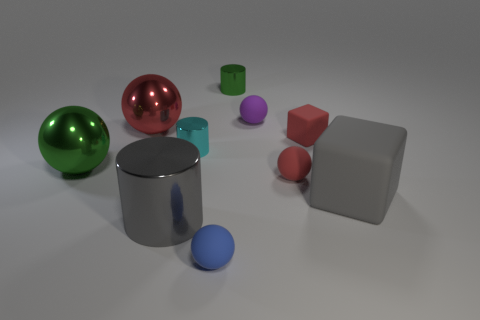The metallic object that is the same color as the large matte thing is what size?
Provide a short and direct response. Large. How many other things are there of the same size as the purple sphere?
Provide a short and direct response. 5. How many large objects are there?
Offer a very short reply. 4. Does the green sphere have the same size as the purple sphere?
Ensure brevity in your answer.  No. How many other things are there of the same shape as the small cyan metal thing?
Offer a very short reply. 2. The cylinder in front of the thing on the right side of the small block is made of what material?
Make the answer very short. Metal. There is a purple ball; are there any metal spheres to the right of it?
Your answer should be very brief. No. There is a green metallic ball; is it the same size as the rubber object to the left of the tiny green thing?
Your answer should be compact. No. There is a purple matte thing that is the same shape as the blue thing; what is its size?
Your response must be concise. Small. Is there anything else that has the same material as the small blue thing?
Give a very brief answer. Yes. 